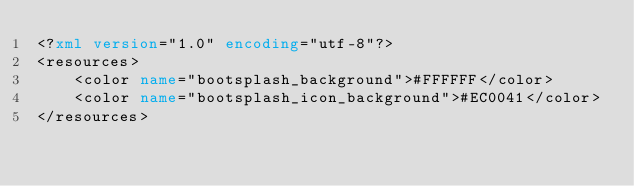Convert code to text. <code><loc_0><loc_0><loc_500><loc_500><_XML_><?xml version="1.0" encoding="utf-8"?>
<resources>
    <color name="bootsplash_background">#FFFFFF</color>
    <color name="bootsplash_icon_background">#EC0041</color>
</resources></code> 